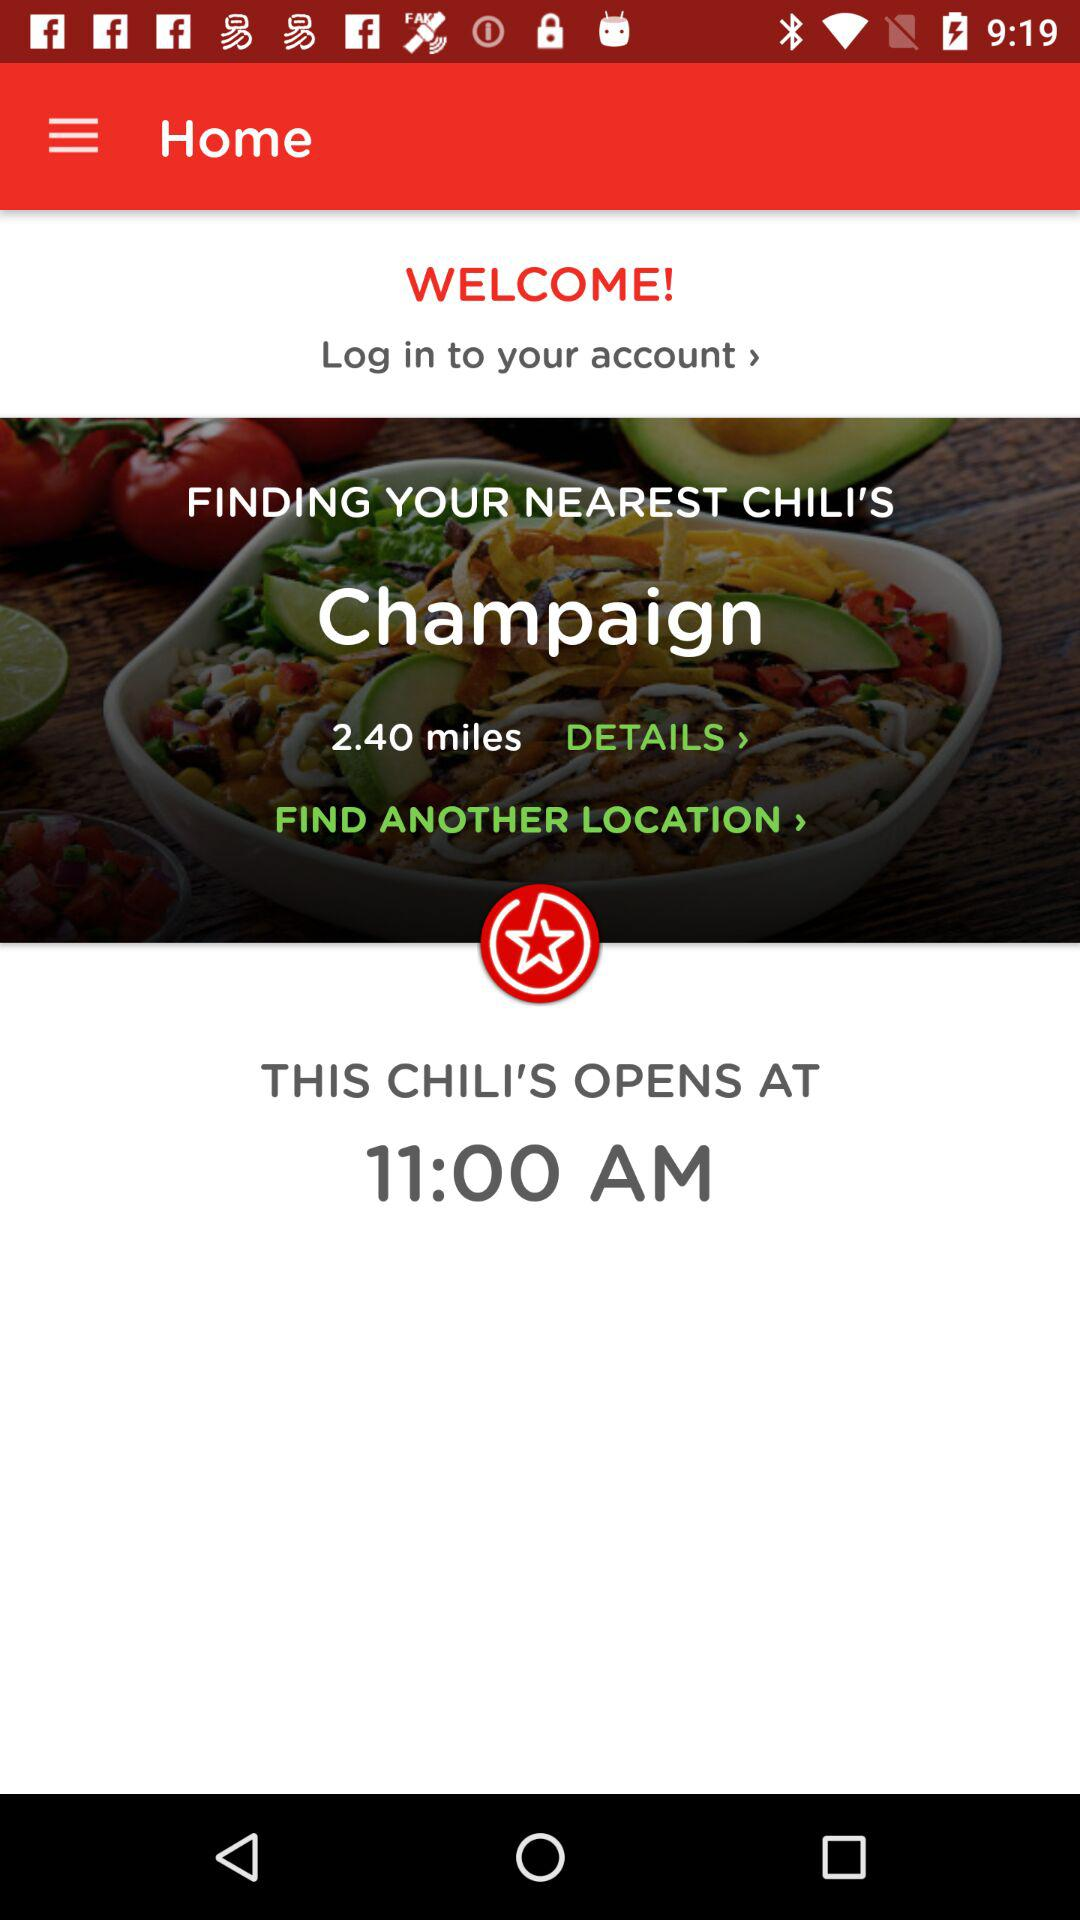What is the distance between the Chili's restaurant and the nearest station?
When the provided information is insufficient, respond with <no answer>. <no answer> 